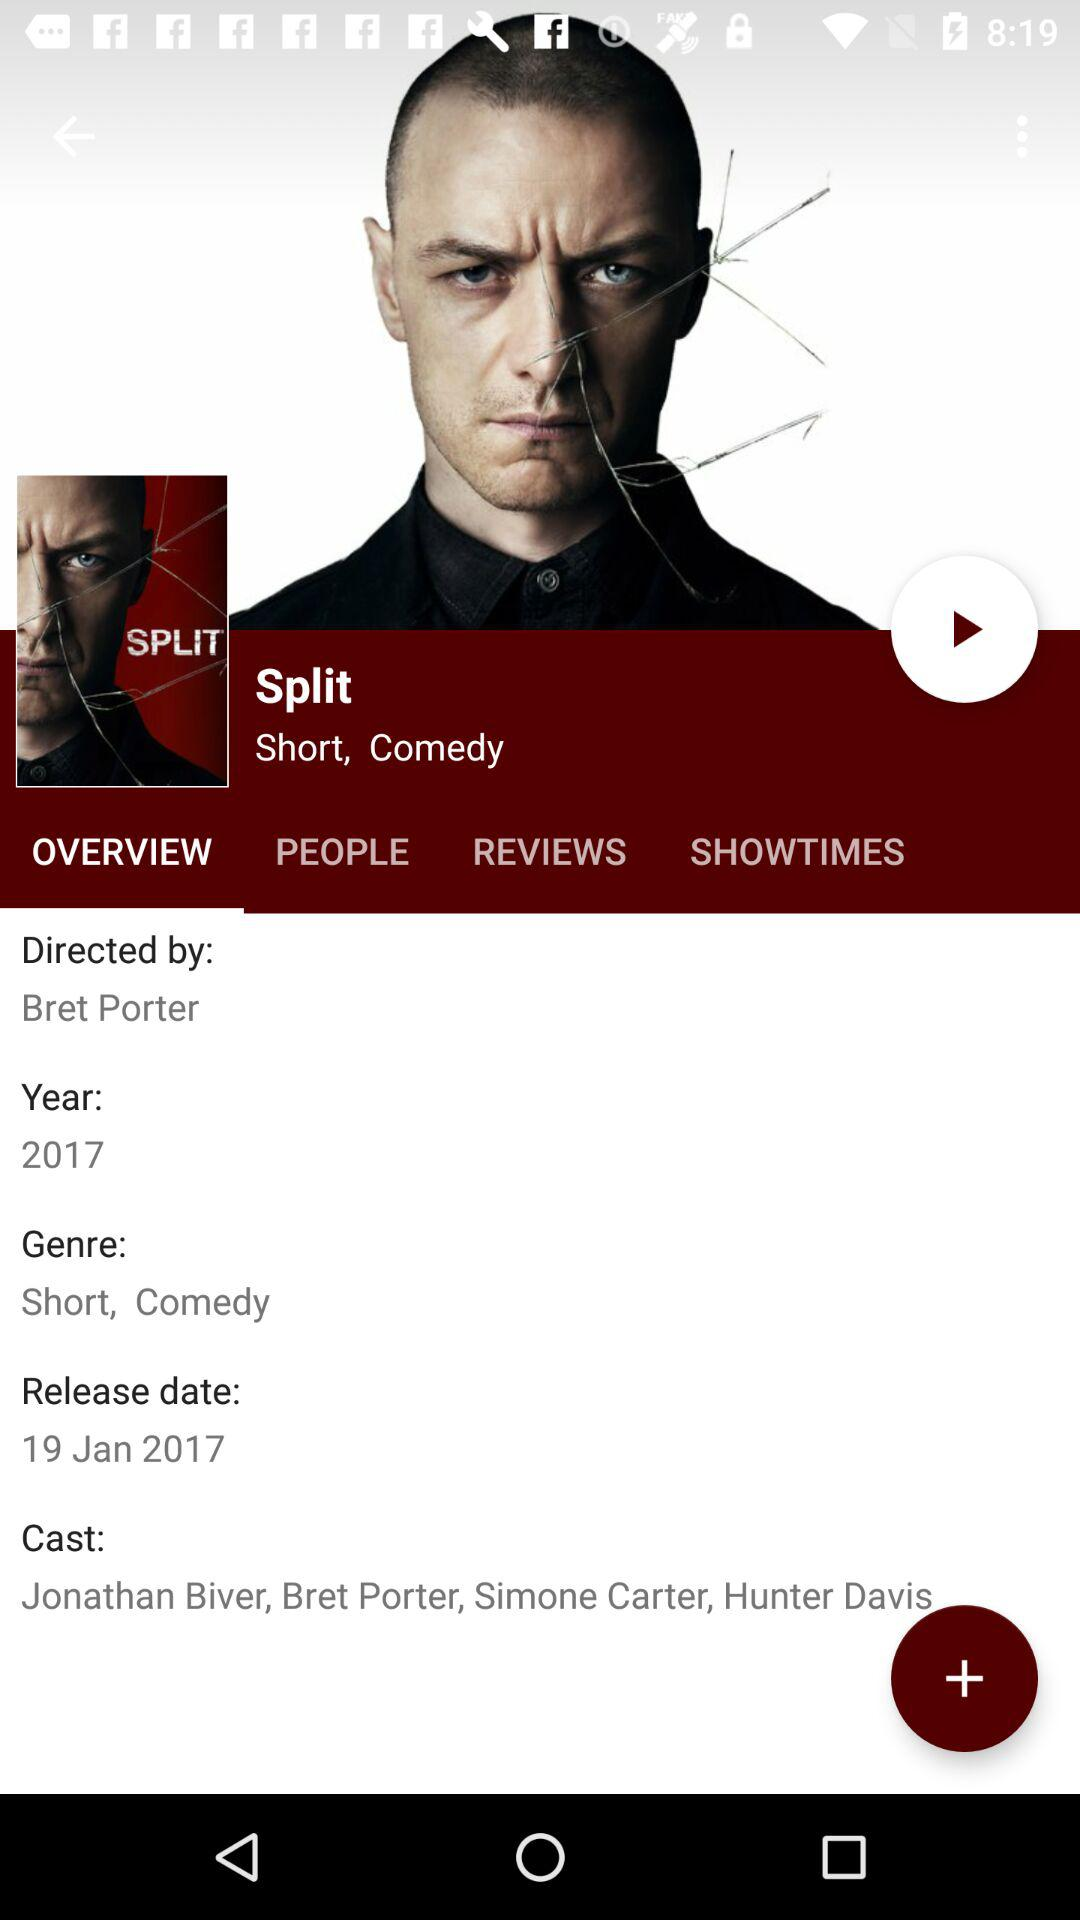What are the cast's names? The cast's names are "Jonathan Biver", "Bret Porter", "Simone Carter" and "Hunter Davis". 